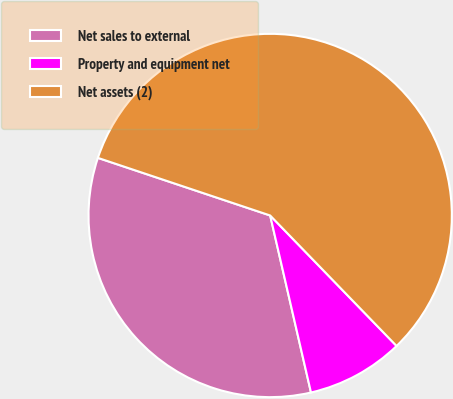Convert chart. <chart><loc_0><loc_0><loc_500><loc_500><pie_chart><fcel>Net sales to external<fcel>Property and equipment net<fcel>Net assets (2)<nl><fcel>33.74%<fcel>8.64%<fcel>57.61%<nl></chart> 